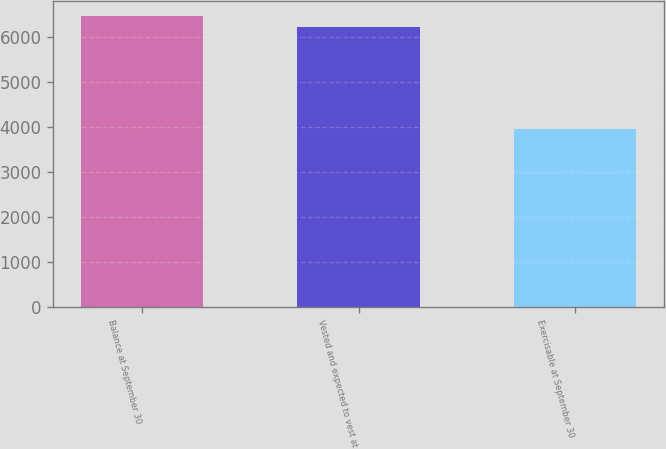Convert chart. <chart><loc_0><loc_0><loc_500><loc_500><bar_chart><fcel>Balance at September 30<fcel>Vested and expected to vest at<fcel>Exercisable at September 30<nl><fcel>6466.4<fcel>6215<fcel>3952<nl></chart> 